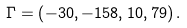<formula> <loc_0><loc_0><loc_500><loc_500>\Gamma = \left ( - 3 0 , - 1 5 8 , 1 0 , 7 9 \right ) .</formula> 